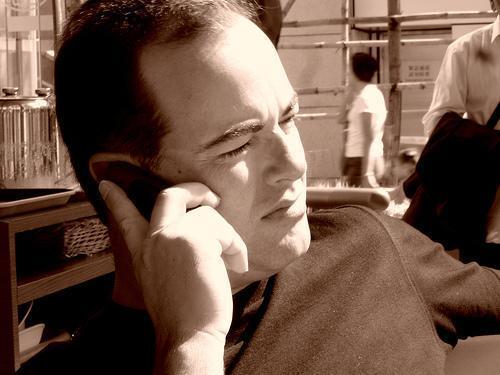How many people are in this photo?
Give a very brief answer. 3. How many people are calling on phone?
Give a very brief answer. 1. 